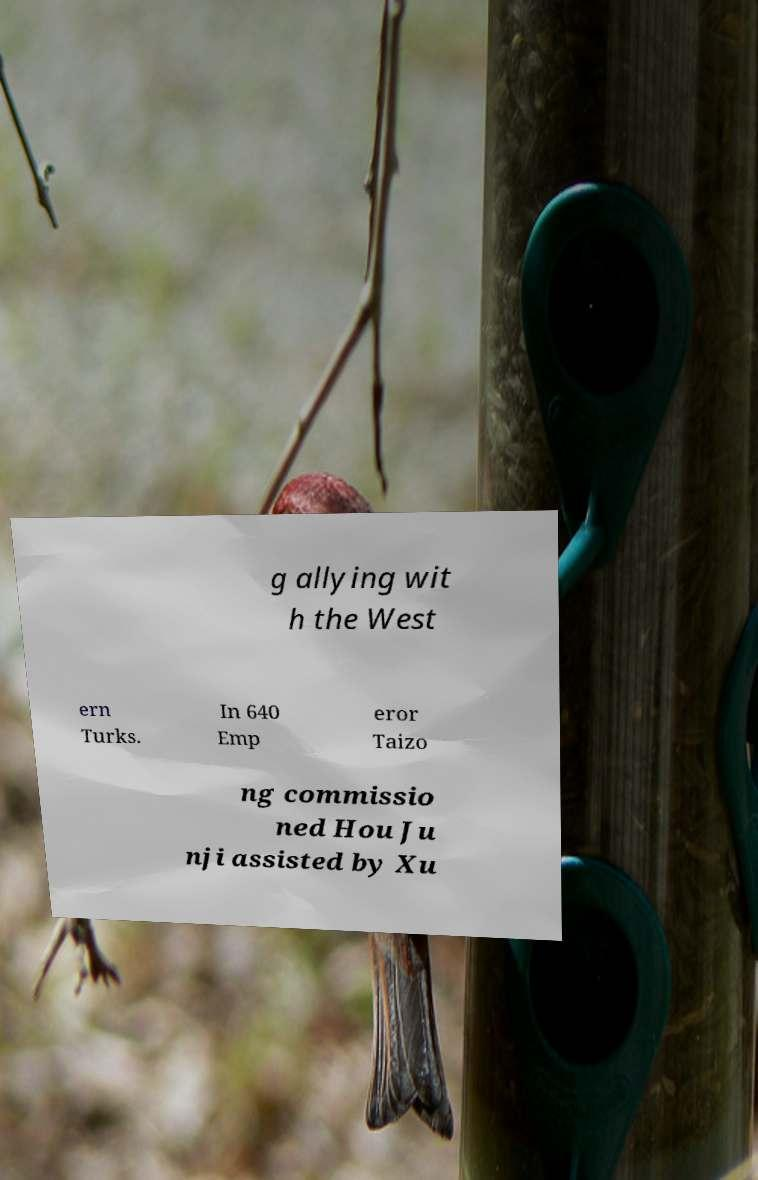Can you read and provide the text displayed in the image?This photo seems to have some interesting text. Can you extract and type it out for me? g allying wit h the West ern Turks. In 640 Emp eror Taizo ng commissio ned Hou Ju nji assisted by Xu 